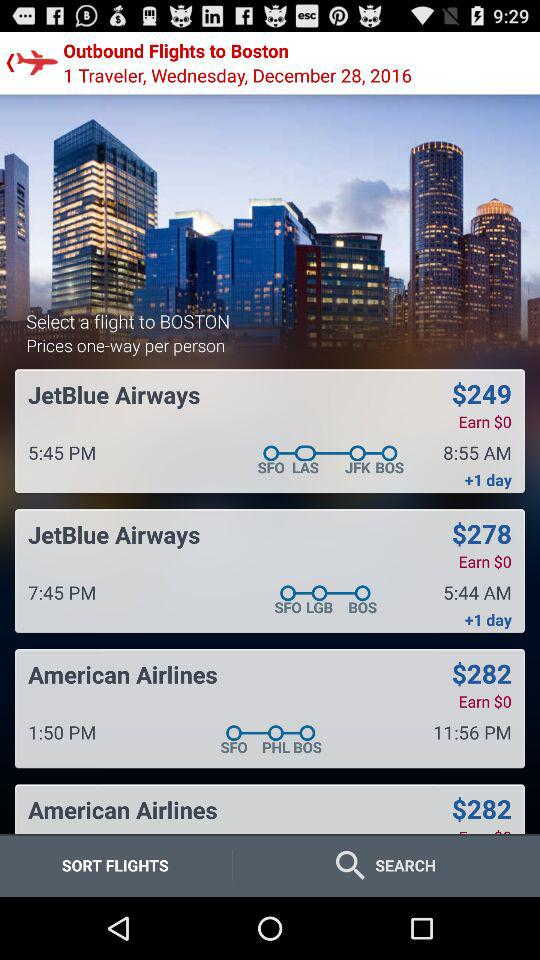When will the flight of "American Airlines" take off? The flight of "American Airlines" will take off at 1:50 p.m. 